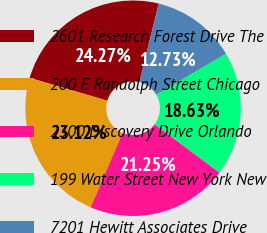Convert chart. <chart><loc_0><loc_0><loc_500><loc_500><pie_chart><fcel>2601 Research Forest Drive The<fcel>200 E Randolph Street Chicago<fcel>2300 Discovery Drive Orlando<fcel>199 Water Street New York New<fcel>7201 Hewitt Associates Drive<nl><fcel>24.27%<fcel>23.12%<fcel>21.25%<fcel>18.63%<fcel>12.73%<nl></chart> 